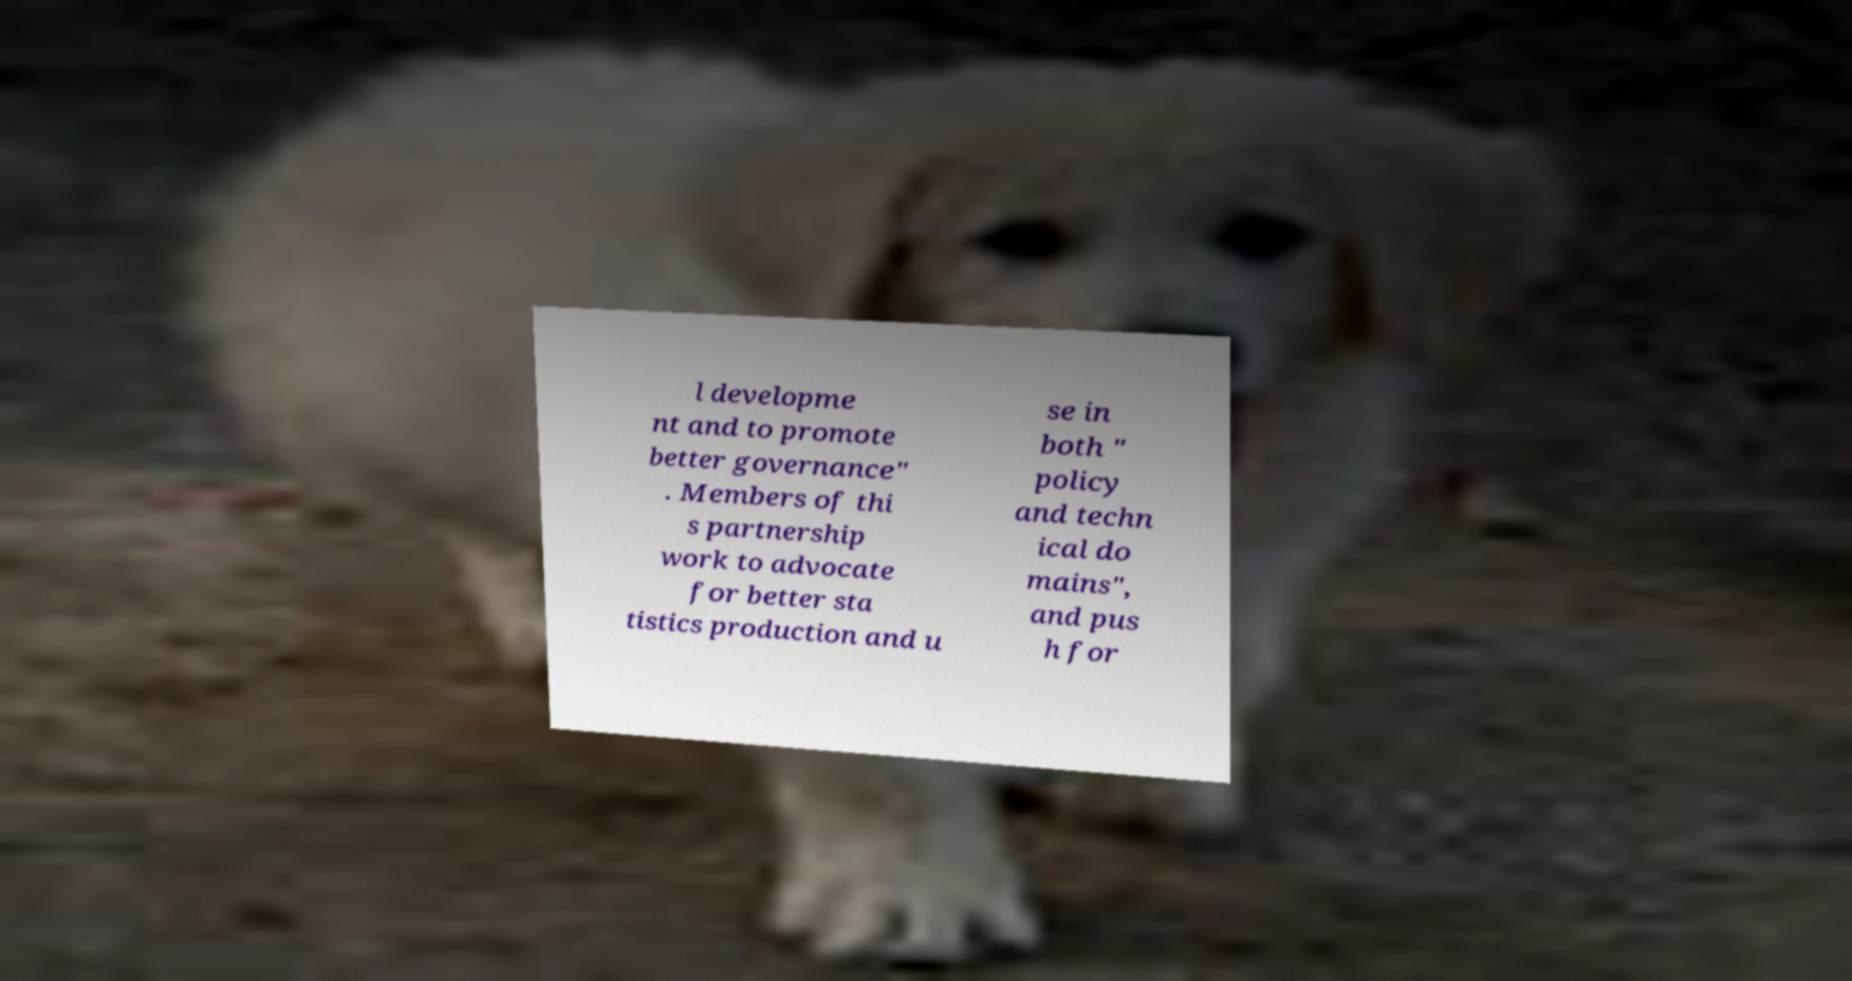For documentation purposes, I need the text within this image transcribed. Could you provide that? l developme nt and to promote better governance" . Members of thi s partnership work to advocate for better sta tistics production and u se in both " policy and techn ical do mains", and pus h for 